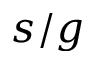Convert formula to latex. <formula><loc_0><loc_0><loc_500><loc_500>s / g</formula> 